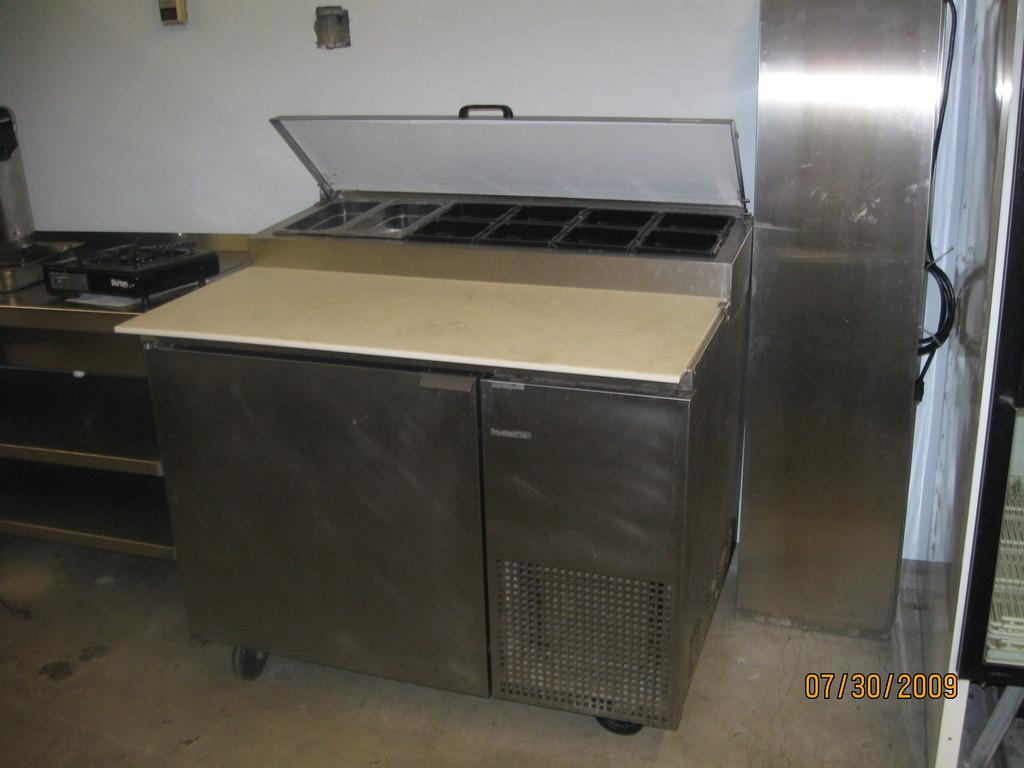<image>
Summarize the visual content of the image. an interior of an industrial kitchen with date stamp of 07/30/2009 